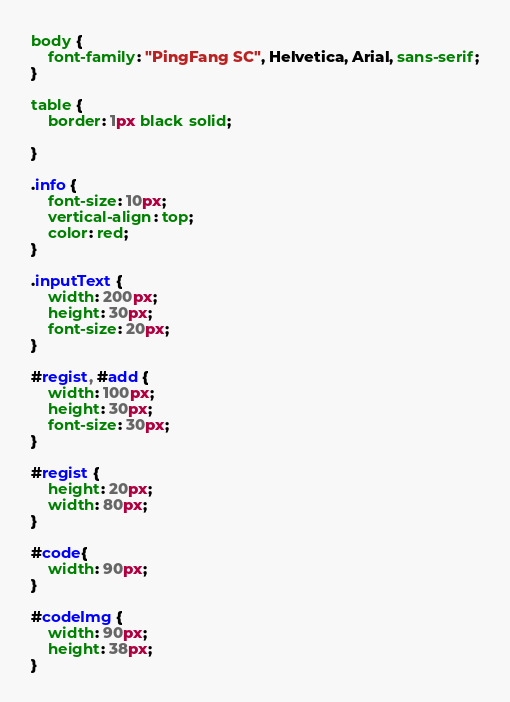<code> <loc_0><loc_0><loc_500><loc_500><_CSS_>body {
    font-family: "PingFang SC", Helvetica, Arial, sans-serif;
}

table {
    border: 1px black solid;

}

.info {
    font-size: 10px;
    vertical-align: top;
    color: red;
}

.inputText {
    width: 200px;
    height: 30px;
    font-size: 20px;
}

#regist, #add {
    width: 100px;
    height: 30px;
    font-size: 30px;
}

#regist {
    height: 20px;
    width: 80px;
}

#code{
    width: 90px;
}

#codeImg {
    width: 90px;
    height: 38px;
}</code> 